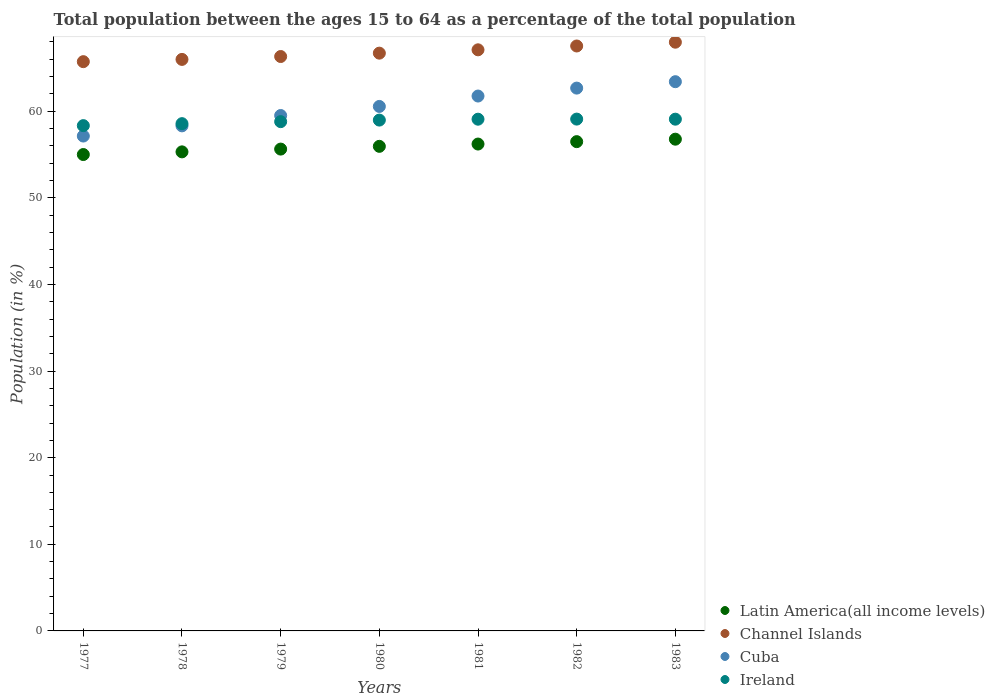How many different coloured dotlines are there?
Provide a succinct answer. 4. Is the number of dotlines equal to the number of legend labels?
Keep it short and to the point. Yes. What is the percentage of the population ages 15 to 64 in Channel Islands in 1980?
Your answer should be compact. 66.71. Across all years, what is the maximum percentage of the population ages 15 to 64 in Latin America(all income levels)?
Your response must be concise. 56.78. Across all years, what is the minimum percentage of the population ages 15 to 64 in Latin America(all income levels)?
Make the answer very short. 55. What is the total percentage of the population ages 15 to 64 in Cuba in the graph?
Offer a very short reply. 423.38. What is the difference between the percentage of the population ages 15 to 64 in Ireland in 1979 and that in 1980?
Your answer should be very brief. -0.18. What is the difference between the percentage of the population ages 15 to 64 in Latin America(all income levels) in 1983 and the percentage of the population ages 15 to 64 in Ireland in 1977?
Make the answer very short. -1.56. What is the average percentage of the population ages 15 to 64 in Latin America(all income levels) per year?
Your answer should be compact. 55.91. In the year 1983, what is the difference between the percentage of the population ages 15 to 64 in Ireland and percentage of the population ages 15 to 64 in Latin America(all income levels)?
Your response must be concise. 2.31. In how many years, is the percentage of the population ages 15 to 64 in Ireland greater than 58?
Give a very brief answer. 7. What is the ratio of the percentage of the population ages 15 to 64 in Ireland in 1977 to that in 1980?
Your answer should be very brief. 0.99. Is the difference between the percentage of the population ages 15 to 64 in Ireland in 1979 and 1980 greater than the difference between the percentage of the population ages 15 to 64 in Latin America(all income levels) in 1979 and 1980?
Provide a succinct answer. Yes. What is the difference between the highest and the second highest percentage of the population ages 15 to 64 in Latin America(all income levels)?
Keep it short and to the point. 0.28. What is the difference between the highest and the lowest percentage of the population ages 15 to 64 in Cuba?
Make the answer very short. 6.28. Is it the case that in every year, the sum of the percentage of the population ages 15 to 64 in Latin America(all income levels) and percentage of the population ages 15 to 64 in Channel Islands  is greater than the sum of percentage of the population ages 15 to 64 in Ireland and percentage of the population ages 15 to 64 in Cuba?
Offer a terse response. Yes. Is it the case that in every year, the sum of the percentage of the population ages 15 to 64 in Ireland and percentage of the population ages 15 to 64 in Cuba  is greater than the percentage of the population ages 15 to 64 in Channel Islands?
Your answer should be very brief. Yes. Does the percentage of the population ages 15 to 64 in Cuba monotonically increase over the years?
Ensure brevity in your answer.  Yes. Is the percentage of the population ages 15 to 64 in Channel Islands strictly less than the percentage of the population ages 15 to 64 in Cuba over the years?
Ensure brevity in your answer.  No. Are the values on the major ticks of Y-axis written in scientific E-notation?
Give a very brief answer. No. Does the graph contain grids?
Give a very brief answer. No. Where does the legend appear in the graph?
Provide a short and direct response. Bottom right. How many legend labels are there?
Your answer should be very brief. 4. How are the legend labels stacked?
Provide a short and direct response. Vertical. What is the title of the graph?
Your response must be concise. Total population between the ages 15 to 64 as a percentage of the total population. What is the label or title of the Y-axis?
Your response must be concise. Population (in %). What is the Population (in %) in Latin America(all income levels) in 1977?
Give a very brief answer. 55. What is the Population (in %) in Channel Islands in 1977?
Your answer should be compact. 65.73. What is the Population (in %) in Cuba in 1977?
Offer a terse response. 57.14. What is the Population (in %) of Ireland in 1977?
Keep it short and to the point. 58.34. What is the Population (in %) of Latin America(all income levels) in 1978?
Offer a terse response. 55.31. What is the Population (in %) in Channel Islands in 1978?
Your answer should be compact. 65.99. What is the Population (in %) in Cuba in 1978?
Your answer should be compact. 58.32. What is the Population (in %) in Ireland in 1978?
Provide a short and direct response. 58.57. What is the Population (in %) in Latin America(all income levels) in 1979?
Keep it short and to the point. 55.63. What is the Population (in %) in Channel Islands in 1979?
Provide a short and direct response. 66.32. What is the Population (in %) of Cuba in 1979?
Make the answer very short. 59.51. What is the Population (in %) of Ireland in 1979?
Offer a terse response. 58.8. What is the Population (in %) of Latin America(all income levels) in 1980?
Make the answer very short. 55.95. What is the Population (in %) of Channel Islands in 1980?
Provide a succinct answer. 66.71. What is the Population (in %) of Cuba in 1980?
Your answer should be compact. 60.56. What is the Population (in %) of Ireland in 1980?
Give a very brief answer. 58.98. What is the Population (in %) in Latin America(all income levels) in 1981?
Your answer should be very brief. 56.22. What is the Population (in %) of Channel Islands in 1981?
Offer a very short reply. 67.1. What is the Population (in %) in Cuba in 1981?
Your response must be concise. 61.76. What is the Population (in %) in Ireland in 1981?
Offer a very short reply. 59.09. What is the Population (in %) of Latin America(all income levels) in 1982?
Give a very brief answer. 56.49. What is the Population (in %) in Channel Islands in 1982?
Make the answer very short. 67.54. What is the Population (in %) in Cuba in 1982?
Offer a terse response. 62.68. What is the Population (in %) in Ireland in 1982?
Provide a succinct answer. 59.1. What is the Population (in %) in Latin America(all income levels) in 1983?
Your answer should be compact. 56.78. What is the Population (in %) in Channel Islands in 1983?
Give a very brief answer. 67.98. What is the Population (in %) of Cuba in 1983?
Provide a succinct answer. 63.42. What is the Population (in %) of Ireland in 1983?
Provide a short and direct response. 59.09. Across all years, what is the maximum Population (in %) of Latin America(all income levels)?
Offer a very short reply. 56.78. Across all years, what is the maximum Population (in %) of Channel Islands?
Your response must be concise. 67.98. Across all years, what is the maximum Population (in %) in Cuba?
Make the answer very short. 63.42. Across all years, what is the maximum Population (in %) in Ireland?
Give a very brief answer. 59.1. Across all years, what is the minimum Population (in %) of Latin America(all income levels)?
Make the answer very short. 55. Across all years, what is the minimum Population (in %) in Channel Islands?
Your answer should be very brief. 65.73. Across all years, what is the minimum Population (in %) of Cuba?
Offer a very short reply. 57.14. Across all years, what is the minimum Population (in %) in Ireland?
Offer a terse response. 58.34. What is the total Population (in %) of Latin America(all income levels) in the graph?
Offer a very short reply. 391.39. What is the total Population (in %) in Channel Islands in the graph?
Offer a very short reply. 467.36. What is the total Population (in %) of Cuba in the graph?
Provide a short and direct response. 423.38. What is the total Population (in %) in Ireland in the graph?
Your answer should be very brief. 411.97. What is the difference between the Population (in %) of Latin America(all income levels) in 1977 and that in 1978?
Your answer should be very brief. -0.31. What is the difference between the Population (in %) of Channel Islands in 1977 and that in 1978?
Give a very brief answer. -0.26. What is the difference between the Population (in %) in Cuba in 1977 and that in 1978?
Your answer should be very brief. -1.18. What is the difference between the Population (in %) of Ireland in 1977 and that in 1978?
Offer a very short reply. -0.23. What is the difference between the Population (in %) of Latin America(all income levels) in 1977 and that in 1979?
Keep it short and to the point. -0.63. What is the difference between the Population (in %) of Channel Islands in 1977 and that in 1979?
Give a very brief answer. -0.59. What is the difference between the Population (in %) in Cuba in 1977 and that in 1979?
Give a very brief answer. -2.37. What is the difference between the Population (in %) in Ireland in 1977 and that in 1979?
Give a very brief answer. -0.46. What is the difference between the Population (in %) in Latin America(all income levels) in 1977 and that in 1980?
Your answer should be compact. -0.95. What is the difference between the Population (in %) in Channel Islands in 1977 and that in 1980?
Make the answer very short. -0.98. What is the difference between the Population (in %) of Cuba in 1977 and that in 1980?
Ensure brevity in your answer.  -3.42. What is the difference between the Population (in %) in Ireland in 1977 and that in 1980?
Ensure brevity in your answer.  -0.64. What is the difference between the Population (in %) in Latin America(all income levels) in 1977 and that in 1981?
Provide a short and direct response. -1.21. What is the difference between the Population (in %) of Channel Islands in 1977 and that in 1981?
Provide a succinct answer. -1.37. What is the difference between the Population (in %) in Cuba in 1977 and that in 1981?
Offer a terse response. -4.62. What is the difference between the Population (in %) of Ireland in 1977 and that in 1981?
Your answer should be very brief. -0.74. What is the difference between the Population (in %) of Latin America(all income levels) in 1977 and that in 1982?
Offer a terse response. -1.49. What is the difference between the Population (in %) of Channel Islands in 1977 and that in 1982?
Give a very brief answer. -1.81. What is the difference between the Population (in %) in Cuba in 1977 and that in 1982?
Your response must be concise. -5.54. What is the difference between the Population (in %) of Ireland in 1977 and that in 1982?
Make the answer very short. -0.76. What is the difference between the Population (in %) of Latin America(all income levels) in 1977 and that in 1983?
Your answer should be very brief. -1.77. What is the difference between the Population (in %) in Channel Islands in 1977 and that in 1983?
Your answer should be compact. -2.25. What is the difference between the Population (in %) in Cuba in 1977 and that in 1983?
Your response must be concise. -6.28. What is the difference between the Population (in %) in Ireland in 1977 and that in 1983?
Make the answer very short. -0.75. What is the difference between the Population (in %) in Latin America(all income levels) in 1978 and that in 1979?
Your response must be concise. -0.32. What is the difference between the Population (in %) of Channel Islands in 1978 and that in 1979?
Make the answer very short. -0.33. What is the difference between the Population (in %) in Cuba in 1978 and that in 1979?
Provide a succinct answer. -1.19. What is the difference between the Population (in %) of Ireland in 1978 and that in 1979?
Give a very brief answer. -0.23. What is the difference between the Population (in %) in Latin America(all income levels) in 1978 and that in 1980?
Ensure brevity in your answer.  -0.64. What is the difference between the Population (in %) in Channel Islands in 1978 and that in 1980?
Ensure brevity in your answer.  -0.72. What is the difference between the Population (in %) of Cuba in 1978 and that in 1980?
Give a very brief answer. -2.24. What is the difference between the Population (in %) of Ireland in 1978 and that in 1980?
Your answer should be very brief. -0.41. What is the difference between the Population (in %) of Latin America(all income levels) in 1978 and that in 1981?
Provide a succinct answer. -0.9. What is the difference between the Population (in %) of Channel Islands in 1978 and that in 1981?
Your answer should be compact. -1.11. What is the difference between the Population (in %) of Cuba in 1978 and that in 1981?
Provide a succinct answer. -3.44. What is the difference between the Population (in %) in Ireland in 1978 and that in 1981?
Your response must be concise. -0.51. What is the difference between the Population (in %) in Latin America(all income levels) in 1978 and that in 1982?
Provide a succinct answer. -1.18. What is the difference between the Population (in %) in Channel Islands in 1978 and that in 1982?
Make the answer very short. -1.55. What is the difference between the Population (in %) in Cuba in 1978 and that in 1982?
Offer a very short reply. -4.36. What is the difference between the Population (in %) in Ireland in 1978 and that in 1982?
Provide a succinct answer. -0.53. What is the difference between the Population (in %) in Latin America(all income levels) in 1978 and that in 1983?
Give a very brief answer. -1.46. What is the difference between the Population (in %) of Channel Islands in 1978 and that in 1983?
Ensure brevity in your answer.  -1.99. What is the difference between the Population (in %) in Cuba in 1978 and that in 1983?
Offer a very short reply. -5.1. What is the difference between the Population (in %) in Ireland in 1978 and that in 1983?
Provide a short and direct response. -0.52. What is the difference between the Population (in %) in Latin America(all income levels) in 1979 and that in 1980?
Give a very brief answer. -0.32. What is the difference between the Population (in %) in Channel Islands in 1979 and that in 1980?
Offer a terse response. -0.39. What is the difference between the Population (in %) in Cuba in 1979 and that in 1980?
Your response must be concise. -1.05. What is the difference between the Population (in %) in Ireland in 1979 and that in 1980?
Keep it short and to the point. -0.18. What is the difference between the Population (in %) of Latin America(all income levels) in 1979 and that in 1981?
Provide a succinct answer. -0.58. What is the difference between the Population (in %) in Channel Islands in 1979 and that in 1981?
Your answer should be very brief. -0.77. What is the difference between the Population (in %) of Cuba in 1979 and that in 1981?
Ensure brevity in your answer.  -2.25. What is the difference between the Population (in %) of Ireland in 1979 and that in 1981?
Provide a succinct answer. -0.28. What is the difference between the Population (in %) of Latin America(all income levels) in 1979 and that in 1982?
Provide a short and direct response. -0.86. What is the difference between the Population (in %) in Channel Islands in 1979 and that in 1982?
Provide a succinct answer. -1.22. What is the difference between the Population (in %) of Cuba in 1979 and that in 1982?
Offer a terse response. -3.17. What is the difference between the Population (in %) in Ireland in 1979 and that in 1982?
Provide a short and direct response. -0.29. What is the difference between the Population (in %) in Latin America(all income levels) in 1979 and that in 1983?
Offer a terse response. -1.14. What is the difference between the Population (in %) of Channel Islands in 1979 and that in 1983?
Make the answer very short. -1.65. What is the difference between the Population (in %) in Cuba in 1979 and that in 1983?
Your answer should be very brief. -3.9. What is the difference between the Population (in %) in Ireland in 1979 and that in 1983?
Give a very brief answer. -0.29. What is the difference between the Population (in %) of Latin America(all income levels) in 1980 and that in 1981?
Provide a short and direct response. -0.26. What is the difference between the Population (in %) in Channel Islands in 1980 and that in 1981?
Ensure brevity in your answer.  -0.38. What is the difference between the Population (in %) of Cuba in 1980 and that in 1981?
Provide a succinct answer. -1.2. What is the difference between the Population (in %) of Ireland in 1980 and that in 1981?
Offer a terse response. -0.1. What is the difference between the Population (in %) in Latin America(all income levels) in 1980 and that in 1982?
Your answer should be very brief. -0.54. What is the difference between the Population (in %) in Channel Islands in 1980 and that in 1982?
Provide a succinct answer. -0.83. What is the difference between the Population (in %) of Cuba in 1980 and that in 1982?
Provide a short and direct response. -2.12. What is the difference between the Population (in %) of Ireland in 1980 and that in 1982?
Ensure brevity in your answer.  -0.11. What is the difference between the Population (in %) in Latin America(all income levels) in 1980 and that in 1983?
Your answer should be compact. -0.83. What is the difference between the Population (in %) of Channel Islands in 1980 and that in 1983?
Keep it short and to the point. -1.27. What is the difference between the Population (in %) of Cuba in 1980 and that in 1983?
Provide a short and direct response. -2.86. What is the difference between the Population (in %) of Ireland in 1980 and that in 1983?
Your answer should be compact. -0.11. What is the difference between the Population (in %) in Latin America(all income levels) in 1981 and that in 1982?
Your answer should be compact. -0.28. What is the difference between the Population (in %) of Channel Islands in 1981 and that in 1982?
Give a very brief answer. -0.44. What is the difference between the Population (in %) of Cuba in 1981 and that in 1982?
Offer a very short reply. -0.92. What is the difference between the Population (in %) of Ireland in 1981 and that in 1982?
Offer a very short reply. -0.01. What is the difference between the Population (in %) of Latin America(all income levels) in 1981 and that in 1983?
Your answer should be compact. -0.56. What is the difference between the Population (in %) in Channel Islands in 1981 and that in 1983?
Offer a terse response. -0.88. What is the difference between the Population (in %) in Cuba in 1981 and that in 1983?
Ensure brevity in your answer.  -1.66. What is the difference between the Population (in %) of Ireland in 1981 and that in 1983?
Your answer should be compact. -0. What is the difference between the Population (in %) in Latin America(all income levels) in 1982 and that in 1983?
Keep it short and to the point. -0.28. What is the difference between the Population (in %) in Channel Islands in 1982 and that in 1983?
Provide a succinct answer. -0.44. What is the difference between the Population (in %) in Cuba in 1982 and that in 1983?
Your answer should be compact. -0.74. What is the difference between the Population (in %) of Ireland in 1982 and that in 1983?
Provide a short and direct response. 0.01. What is the difference between the Population (in %) of Latin America(all income levels) in 1977 and the Population (in %) of Channel Islands in 1978?
Your answer should be compact. -10.98. What is the difference between the Population (in %) in Latin America(all income levels) in 1977 and the Population (in %) in Cuba in 1978?
Your answer should be very brief. -3.31. What is the difference between the Population (in %) in Latin America(all income levels) in 1977 and the Population (in %) in Ireland in 1978?
Your response must be concise. -3.57. What is the difference between the Population (in %) in Channel Islands in 1977 and the Population (in %) in Cuba in 1978?
Keep it short and to the point. 7.41. What is the difference between the Population (in %) in Channel Islands in 1977 and the Population (in %) in Ireland in 1978?
Provide a succinct answer. 7.16. What is the difference between the Population (in %) in Cuba in 1977 and the Population (in %) in Ireland in 1978?
Provide a short and direct response. -1.43. What is the difference between the Population (in %) in Latin America(all income levels) in 1977 and the Population (in %) in Channel Islands in 1979?
Your response must be concise. -11.32. What is the difference between the Population (in %) of Latin America(all income levels) in 1977 and the Population (in %) of Cuba in 1979?
Offer a very short reply. -4.51. What is the difference between the Population (in %) of Latin America(all income levels) in 1977 and the Population (in %) of Ireland in 1979?
Offer a very short reply. -3.8. What is the difference between the Population (in %) of Channel Islands in 1977 and the Population (in %) of Cuba in 1979?
Offer a very short reply. 6.22. What is the difference between the Population (in %) in Channel Islands in 1977 and the Population (in %) in Ireland in 1979?
Give a very brief answer. 6.93. What is the difference between the Population (in %) in Cuba in 1977 and the Population (in %) in Ireland in 1979?
Provide a succinct answer. -1.66. What is the difference between the Population (in %) of Latin America(all income levels) in 1977 and the Population (in %) of Channel Islands in 1980?
Make the answer very short. -11.71. What is the difference between the Population (in %) in Latin America(all income levels) in 1977 and the Population (in %) in Cuba in 1980?
Your answer should be very brief. -5.55. What is the difference between the Population (in %) in Latin America(all income levels) in 1977 and the Population (in %) in Ireland in 1980?
Give a very brief answer. -3.98. What is the difference between the Population (in %) of Channel Islands in 1977 and the Population (in %) of Cuba in 1980?
Make the answer very short. 5.17. What is the difference between the Population (in %) in Channel Islands in 1977 and the Population (in %) in Ireland in 1980?
Your response must be concise. 6.75. What is the difference between the Population (in %) in Cuba in 1977 and the Population (in %) in Ireland in 1980?
Give a very brief answer. -1.84. What is the difference between the Population (in %) of Latin America(all income levels) in 1977 and the Population (in %) of Channel Islands in 1981?
Offer a very short reply. -12.09. What is the difference between the Population (in %) in Latin America(all income levels) in 1977 and the Population (in %) in Cuba in 1981?
Provide a succinct answer. -6.75. What is the difference between the Population (in %) of Latin America(all income levels) in 1977 and the Population (in %) of Ireland in 1981?
Provide a short and direct response. -4.08. What is the difference between the Population (in %) in Channel Islands in 1977 and the Population (in %) in Cuba in 1981?
Keep it short and to the point. 3.97. What is the difference between the Population (in %) in Channel Islands in 1977 and the Population (in %) in Ireland in 1981?
Keep it short and to the point. 6.64. What is the difference between the Population (in %) of Cuba in 1977 and the Population (in %) of Ireland in 1981?
Provide a short and direct response. -1.95. What is the difference between the Population (in %) of Latin America(all income levels) in 1977 and the Population (in %) of Channel Islands in 1982?
Give a very brief answer. -12.53. What is the difference between the Population (in %) in Latin America(all income levels) in 1977 and the Population (in %) in Cuba in 1982?
Ensure brevity in your answer.  -7.67. What is the difference between the Population (in %) in Latin America(all income levels) in 1977 and the Population (in %) in Ireland in 1982?
Offer a very short reply. -4.09. What is the difference between the Population (in %) in Channel Islands in 1977 and the Population (in %) in Cuba in 1982?
Provide a short and direct response. 3.05. What is the difference between the Population (in %) in Channel Islands in 1977 and the Population (in %) in Ireland in 1982?
Provide a succinct answer. 6.63. What is the difference between the Population (in %) of Cuba in 1977 and the Population (in %) of Ireland in 1982?
Your answer should be very brief. -1.96. What is the difference between the Population (in %) in Latin America(all income levels) in 1977 and the Population (in %) in Channel Islands in 1983?
Give a very brief answer. -12.97. What is the difference between the Population (in %) in Latin America(all income levels) in 1977 and the Population (in %) in Cuba in 1983?
Ensure brevity in your answer.  -8.41. What is the difference between the Population (in %) in Latin America(all income levels) in 1977 and the Population (in %) in Ireland in 1983?
Your answer should be very brief. -4.08. What is the difference between the Population (in %) of Channel Islands in 1977 and the Population (in %) of Cuba in 1983?
Make the answer very short. 2.31. What is the difference between the Population (in %) in Channel Islands in 1977 and the Population (in %) in Ireland in 1983?
Make the answer very short. 6.64. What is the difference between the Population (in %) of Cuba in 1977 and the Population (in %) of Ireland in 1983?
Your response must be concise. -1.95. What is the difference between the Population (in %) in Latin America(all income levels) in 1978 and the Population (in %) in Channel Islands in 1979?
Your response must be concise. -11.01. What is the difference between the Population (in %) of Latin America(all income levels) in 1978 and the Population (in %) of Cuba in 1979?
Ensure brevity in your answer.  -4.2. What is the difference between the Population (in %) of Latin America(all income levels) in 1978 and the Population (in %) of Ireland in 1979?
Your answer should be very brief. -3.49. What is the difference between the Population (in %) of Channel Islands in 1978 and the Population (in %) of Cuba in 1979?
Make the answer very short. 6.48. What is the difference between the Population (in %) of Channel Islands in 1978 and the Population (in %) of Ireland in 1979?
Make the answer very short. 7.19. What is the difference between the Population (in %) in Cuba in 1978 and the Population (in %) in Ireland in 1979?
Provide a succinct answer. -0.49. What is the difference between the Population (in %) of Latin America(all income levels) in 1978 and the Population (in %) of Channel Islands in 1980?
Your answer should be compact. -11.4. What is the difference between the Population (in %) in Latin America(all income levels) in 1978 and the Population (in %) in Cuba in 1980?
Ensure brevity in your answer.  -5.24. What is the difference between the Population (in %) in Latin America(all income levels) in 1978 and the Population (in %) in Ireland in 1980?
Make the answer very short. -3.67. What is the difference between the Population (in %) of Channel Islands in 1978 and the Population (in %) of Cuba in 1980?
Offer a very short reply. 5.43. What is the difference between the Population (in %) of Channel Islands in 1978 and the Population (in %) of Ireland in 1980?
Your response must be concise. 7.01. What is the difference between the Population (in %) of Cuba in 1978 and the Population (in %) of Ireland in 1980?
Offer a terse response. -0.67. What is the difference between the Population (in %) of Latin America(all income levels) in 1978 and the Population (in %) of Channel Islands in 1981?
Keep it short and to the point. -11.78. What is the difference between the Population (in %) in Latin America(all income levels) in 1978 and the Population (in %) in Cuba in 1981?
Offer a terse response. -6.44. What is the difference between the Population (in %) in Latin America(all income levels) in 1978 and the Population (in %) in Ireland in 1981?
Offer a terse response. -3.77. What is the difference between the Population (in %) of Channel Islands in 1978 and the Population (in %) of Cuba in 1981?
Your response must be concise. 4.23. What is the difference between the Population (in %) in Channel Islands in 1978 and the Population (in %) in Ireland in 1981?
Offer a very short reply. 6.9. What is the difference between the Population (in %) in Cuba in 1978 and the Population (in %) in Ireland in 1981?
Offer a very short reply. -0.77. What is the difference between the Population (in %) in Latin America(all income levels) in 1978 and the Population (in %) in Channel Islands in 1982?
Provide a succinct answer. -12.22. What is the difference between the Population (in %) of Latin America(all income levels) in 1978 and the Population (in %) of Cuba in 1982?
Offer a very short reply. -7.36. What is the difference between the Population (in %) of Latin America(all income levels) in 1978 and the Population (in %) of Ireland in 1982?
Make the answer very short. -3.78. What is the difference between the Population (in %) of Channel Islands in 1978 and the Population (in %) of Cuba in 1982?
Keep it short and to the point. 3.31. What is the difference between the Population (in %) in Channel Islands in 1978 and the Population (in %) in Ireland in 1982?
Your answer should be compact. 6.89. What is the difference between the Population (in %) of Cuba in 1978 and the Population (in %) of Ireland in 1982?
Give a very brief answer. -0.78. What is the difference between the Population (in %) of Latin America(all income levels) in 1978 and the Population (in %) of Channel Islands in 1983?
Your response must be concise. -12.66. What is the difference between the Population (in %) in Latin America(all income levels) in 1978 and the Population (in %) in Cuba in 1983?
Provide a short and direct response. -8.1. What is the difference between the Population (in %) of Latin America(all income levels) in 1978 and the Population (in %) of Ireland in 1983?
Provide a short and direct response. -3.77. What is the difference between the Population (in %) of Channel Islands in 1978 and the Population (in %) of Cuba in 1983?
Your response must be concise. 2.57. What is the difference between the Population (in %) in Channel Islands in 1978 and the Population (in %) in Ireland in 1983?
Provide a short and direct response. 6.9. What is the difference between the Population (in %) in Cuba in 1978 and the Population (in %) in Ireland in 1983?
Ensure brevity in your answer.  -0.77. What is the difference between the Population (in %) in Latin America(all income levels) in 1979 and the Population (in %) in Channel Islands in 1980?
Provide a succinct answer. -11.08. What is the difference between the Population (in %) in Latin America(all income levels) in 1979 and the Population (in %) in Cuba in 1980?
Ensure brevity in your answer.  -4.92. What is the difference between the Population (in %) in Latin America(all income levels) in 1979 and the Population (in %) in Ireland in 1980?
Keep it short and to the point. -3.35. What is the difference between the Population (in %) in Channel Islands in 1979 and the Population (in %) in Cuba in 1980?
Offer a very short reply. 5.76. What is the difference between the Population (in %) of Channel Islands in 1979 and the Population (in %) of Ireland in 1980?
Your answer should be compact. 7.34. What is the difference between the Population (in %) of Cuba in 1979 and the Population (in %) of Ireland in 1980?
Offer a very short reply. 0.53. What is the difference between the Population (in %) in Latin America(all income levels) in 1979 and the Population (in %) in Channel Islands in 1981?
Provide a short and direct response. -11.46. What is the difference between the Population (in %) in Latin America(all income levels) in 1979 and the Population (in %) in Cuba in 1981?
Make the answer very short. -6.12. What is the difference between the Population (in %) of Latin America(all income levels) in 1979 and the Population (in %) of Ireland in 1981?
Offer a terse response. -3.45. What is the difference between the Population (in %) in Channel Islands in 1979 and the Population (in %) in Cuba in 1981?
Keep it short and to the point. 4.56. What is the difference between the Population (in %) in Channel Islands in 1979 and the Population (in %) in Ireland in 1981?
Your answer should be very brief. 7.24. What is the difference between the Population (in %) in Cuba in 1979 and the Population (in %) in Ireland in 1981?
Keep it short and to the point. 0.43. What is the difference between the Population (in %) in Latin America(all income levels) in 1979 and the Population (in %) in Channel Islands in 1982?
Ensure brevity in your answer.  -11.9. What is the difference between the Population (in %) in Latin America(all income levels) in 1979 and the Population (in %) in Cuba in 1982?
Your answer should be compact. -7.04. What is the difference between the Population (in %) in Latin America(all income levels) in 1979 and the Population (in %) in Ireland in 1982?
Offer a terse response. -3.46. What is the difference between the Population (in %) of Channel Islands in 1979 and the Population (in %) of Cuba in 1982?
Offer a very short reply. 3.65. What is the difference between the Population (in %) in Channel Islands in 1979 and the Population (in %) in Ireland in 1982?
Provide a short and direct response. 7.23. What is the difference between the Population (in %) of Cuba in 1979 and the Population (in %) of Ireland in 1982?
Offer a very short reply. 0.41. What is the difference between the Population (in %) of Latin America(all income levels) in 1979 and the Population (in %) of Channel Islands in 1983?
Keep it short and to the point. -12.34. What is the difference between the Population (in %) of Latin America(all income levels) in 1979 and the Population (in %) of Cuba in 1983?
Give a very brief answer. -7.78. What is the difference between the Population (in %) of Latin America(all income levels) in 1979 and the Population (in %) of Ireland in 1983?
Offer a terse response. -3.45. What is the difference between the Population (in %) of Channel Islands in 1979 and the Population (in %) of Cuba in 1983?
Your answer should be very brief. 2.91. What is the difference between the Population (in %) of Channel Islands in 1979 and the Population (in %) of Ireland in 1983?
Your answer should be compact. 7.23. What is the difference between the Population (in %) of Cuba in 1979 and the Population (in %) of Ireland in 1983?
Your answer should be compact. 0.42. What is the difference between the Population (in %) in Latin America(all income levels) in 1980 and the Population (in %) in Channel Islands in 1981?
Offer a very short reply. -11.14. What is the difference between the Population (in %) in Latin America(all income levels) in 1980 and the Population (in %) in Cuba in 1981?
Your answer should be very brief. -5.81. What is the difference between the Population (in %) in Latin America(all income levels) in 1980 and the Population (in %) in Ireland in 1981?
Offer a very short reply. -3.13. What is the difference between the Population (in %) in Channel Islands in 1980 and the Population (in %) in Cuba in 1981?
Provide a succinct answer. 4.95. What is the difference between the Population (in %) of Channel Islands in 1980 and the Population (in %) of Ireland in 1981?
Give a very brief answer. 7.63. What is the difference between the Population (in %) of Cuba in 1980 and the Population (in %) of Ireland in 1981?
Make the answer very short. 1.47. What is the difference between the Population (in %) in Latin America(all income levels) in 1980 and the Population (in %) in Channel Islands in 1982?
Your response must be concise. -11.59. What is the difference between the Population (in %) of Latin America(all income levels) in 1980 and the Population (in %) of Cuba in 1982?
Offer a very short reply. -6.72. What is the difference between the Population (in %) in Latin America(all income levels) in 1980 and the Population (in %) in Ireland in 1982?
Your answer should be compact. -3.15. What is the difference between the Population (in %) in Channel Islands in 1980 and the Population (in %) in Cuba in 1982?
Provide a short and direct response. 4.04. What is the difference between the Population (in %) of Channel Islands in 1980 and the Population (in %) of Ireland in 1982?
Ensure brevity in your answer.  7.61. What is the difference between the Population (in %) of Cuba in 1980 and the Population (in %) of Ireland in 1982?
Provide a succinct answer. 1.46. What is the difference between the Population (in %) of Latin America(all income levels) in 1980 and the Population (in %) of Channel Islands in 1983?
Make the answer very short. -12.02. What is the difference between the Population (in %) of Latin America(all income levels) in 1980 and the Population (in %) of Cuba in 1983?
Provide a succinct answer. -7.46. What is the difference between the Population (in %) in Latin America(all income levels) in 1980 and the Population (in %) in Ireland in 1983?
Provide a succinct answer. -3.14. What is the difference between the Population (in %) of Channel Islands in 1980 and the Population (in %) of Cuba in 1983?
Keep it short and to the point. 3.3. What is the difference between the Population (in %) of Channel Islands in 1980 and the Population (in %) of Ireland in 1983?
Your answer should be compact. 7.62. What is the difference between the Population (in %) in Cuba in 1980 and the Population (in %) in Ireland in 1983?
Provide a short and direct response. 1.47. What is the difference between the Population (in %) of Latin America(all income levels) in 1981 and the Population (in %) of Channel Islands in 1982?
Provide a short and direct response. -11.32. What is the difference between the Population (in %) in Latin America(all income levels) in 1981 and the Population (in %) in Cuba in 1982?
Provide a short and direct response. -6.46. What is the difference between the Population (in %) in Latin America(all income levels) in 1981 and the Population (in %) in Ireland in 1982?
Ensure brevity in your answer.  -2.88. What is the difference between the Population (in %) of Channel Islands in 1981 and the Population (in %) of Cuba in 1982?
Keep it short and to the point. 4.42. What is the difference between the Population (in %) in Channel Islands in 1981 and the Population (in %) in Ireland in 1982?
Ensure brevity in your answer.  8. What is the difference between the Population (in %) of Cuba in 1981 and the Population (in %) of Ireland in 1982?
Your response must be concise. 2.66. What is the difference between the Population (in %) of Latin America(all income levels) in 1981 and the Population (in %) of Channel Islands in 1983?
Give a very brief answer. -11.76. What is the difference between the Population (in %) of Latin America(all income levels) in 1981 and the Population (in %) of Cuba in 1983?
Keep it short and to the point. -7.2. What is the difference between the Population (in %) of Latin America(all income levels) in 1981 and the Population (in %) of Ireland in 1983?
Provide a succinct answer. -2.87. What is the difference between the Population (in %) in Channel Islands in 1981 and the Population (in %) in Cuba in 1983?
Offer a terse response. 3.68. What is the difference between the Population (in %) in Channel Islands in 1981 and the Population (in %) in Ireland in 1983?
Offer a terse response. 8.01. What is the difference between the Population (in %) in Cuba in 1981 and the Population (in %) in Ireland in 1983?
Make the answer very short. 2.67. What is the difference between the Population (in %) in Latin America(all income levels) in 1982 and the Population (in %) in Channel Islands in 1983?
Give a very brief answer. -11.48. What is the difference between the Population (in %) in Latin America(all income levels) in 1982 and the Population (in %) in Cuba in 1983?
Offer a very short reply. -6.92. What is the difference between the Population (in %) of Latin America(all income levels) in 1982 and the Population (in %) of Ireland in 1983?
Offer a very short reply. -2.59. What is the difference between the Population (in %) of Channel Islands in 1982 and the Population (in %) of Cuba in 1983?
Offer a terse response. 4.12. What is the difference between the Population (in %) of Channel Islands in 1982 and the Population (in %) of Ireland in 1983?
Ensure brevity in your answer.  8.45. What is the difference between the Population (in %) of Cuba in 1982 and the Population (in %) of Ireland in 1983?
Provide a succinct answer. 3.59. What is the average Population (in %) of Latin America(all income levels) per year?
Ensure brevity in your answer.  55.91. What is the average Population (in %) in Channel Islands per year?
Keep it short and to the point. 66.77. What is the average Population (in %) in Cuba per year?
Your answer should be compact. 60.48. What is the average Population (in %) of Ireland per year?
Provide a succinct answer. 58.85. In the year 1977, what is the difference between the Population (in %) of Latin America(all income levels) and Population (in %) of Channel Islands?
Give a very brief answer. -10.72. In the year 1977, what is the difference between the Population (in %) of Latin America(all income levels) and Population (in %) of Cuba?
Offer a terse response. -2.14. In the year 1977, what is the difference between the Population (in %) in Latin America(all income levels) and Population (in %) in Ireland?
Ensure brevity in your answer.  -3.34. In the year 1977, what is the difference between the Population (in %) of Channel Islands and Population (in %) of Cuba?
Your answer should be compact. 8.59. In the year 1977, what is the difference between the Population (in %) of Channel Islands and Population (in %) of Ireland?
Offer a very short reply. 7.39. In the year 1977, what is the difference between the Population (in %) in Cuba and Population (in %) in Ireland?
Your response must be concise. -1.2. In the year 1978, what is the difference between the Population (in %) of Latin America(all income levels) and Population (in %) of Channel Islands?
Keep it short and to the point. -10.67. In the year 1978, what is the difference between the Population (in %) in Latin America(all income levels) and Population (in %) in Cuba?
Keep it short and to the point. -3. In the year 1978, what is the difference between the Population (in %) in Latin America(all income levels) and Population (in %) in Ireland?
Provide a succinct answer. -3.26. In the year 1978, what is the difference between the Population (in %) of Channel Islands and Population (in %) of Cuba?
Your answer should be very brief. 7.67. In the year 1978, what is the difference between the Population (in %) of Channel Islands and Population (in %) of Ireland?
Make the answer very short. 7.42. In the year 1978, what is the difference between the Population (in %) of Cuba and Population (in %) of Ireland?
Ensure brevity in your answer.  -0.25. In the year 1979, what is the difference between the Population (in %) in Latin America(all income levels) and Population (in %) in Channel Islands?
Give a very brief answer. -10.69. In the year 1979, what is the difference between the Population (in %) of Latin America(all income levels) and Population (in %) of Cuba?
Offer a very short reply. -3.88. In the year 1979, what is the difference between the Population (in %) in Latin America(all income levels) and Population (in %) in Ireland?
Your answer should be very brief. -3.17. In the year 1979, what is the difference between the Population (in %) of Channel Islands and Population (in %) of Cuba?
Keep it short and to the point. 6.81. In the year 1979, what is the difference between the Population (in %) in Channel Islands and Population (in %) in Ireland?
Provide a short and direct response. 7.52. In the year 1979, what is the difference between the Population (in %) of Cuba and Population (in %) of Ireland?
Provide a short and direct response. 0.71. In the year 1980, what is the difference between the Population (in %) in Latin America(all income levels) and Population (in %) in Channel Islands?
Ensure brevity in your answer.  -10.76. In the year 1980, what is the difference between the Population (in %) in Latin America(all income levels) and Population (in %) in Cuba?
Your answer should be very brief. -4.61. In the year 1980, what is the difference between the Population (in %) in Latin America(all income levels) and Population (in %) in Ireland?
Provide a short and direct response. -3.03. In the year 1980, what is the difference between the Population (in %) of Channel Islands and Population (in %) of Cuba?
Ensure brevity in your answer.  6.15. In the year 1980, what is the difference between the Population (in %) of Channel Islands and Population (in %) of Ireland?
Give a very brief answer. 7.73. In the year 1980, what is the difference between the Population (in %) of Cuba and Population (in %) of Ireland?
Your answer should be compact. 1.58. In the year 1981, what is the difference between the Population (in %) in Latin America(all income levels) and Population (in %) in Channel Islands?
Ensure brevity in your answer.  -10.88. In the year 1981, what is the difference between the Population (in %) of Latin America(all income levels) and Population (in %) of Cuba?
Ensure brevity in your answer.  -5.54. In the year 1981, what is the difference between the Population (in %) of Latin America(all income levels) and Population (in %) of Ireland?
Offer a terse response. -2.87. In the year 1981, what is the difference between the Population (in %) in Channel Islands and Population (in %) in Cuba?
Keep it short and to the point. 5.34. In the year 1981, what is the difference between the Population (in %) in Channel Islands and Population (in %) in Ireland?
Keep it short and to the point. 8.01. In the year 1981, what is the difference between the Population (in %) of Cuba and Population (in %) of Ireland?
Your answer should be very brief. 2.67. In the year 1982, what is the difference between the Population (in %) of Latin America(all income levels) and Population (in %) of Channel Islands?
Give a very brief answer. -11.05. In the year 1982, what is the difference between the Population (in %) of Latin America(all income levels) and Population (in %) of Cuba?
Your answer should be compact. -6.18. In the year 1982, what is the difference between the Population (in %) of Latin America(all income levels) and Population (in %) of Ireland?
Ensure brevity in your answer.  -2.6. In the year 1982, what is the difference between the Population (in %) of Channel Islands and Population (in %) of Cuba?
Provide a short and direct response. 4.86. In the year 1982, what is the difference between the Population (in %) in Channel Islands and Population (in %) in Ireland?
Provide a short and direct response. 8.44. In the year 1982, what is the difference between the Population (in %) in Cuba and Population (in %) in Ireland?
Your answer should be very brief. 3.58. In the year 1983, what is the difference between the Population (in %) in Latin America(all income levels) and Population (in %) in Channel Islands?
Make the answer very short. -11.2. In the year 1983, what is the difference between the Population (in %) in Latin America(all income levels) and Population (in %) in Cuba?
Give a very brief answer. -6.64. In the year 1983, what is the difference between the Population (in %) in Latin America(all income levels) and Population (in %) in Ireland?
Provide a short and direct response. -2.31. In the year 1983, what is the difference between the Population (in %) in Channel Islands and Population (in %) in Cuba?
Your answer should be very brief. 4.56. In the year 1983, what is the difference between the Population (in %) in Channel Islands and Population (in %) in Ireland?
Offer a very short reply. 8.89. In the year 1983, what is the difference between the Population (in %) in Cuba and Population (in %) in Ireland?
Provide a succinct answer. 4.33. What is the ratio of the Population (in %) in Latin America(all income levels) in 1977 to that in 1978?
Give a very brief answer. 0.99. What is the ratio of the Population (in %) in Channel Islands in 1977 to that in 1978?
Keep it short and to the point. 1. What is the ratio of the Population (in %) in Cuba in 1977 to that in 1978?
Keep it short and to the point. 0.98. What is the ratio of the Population (in %) in Latin America(all income levels) in 1977 to that in 1979?
Keep it short and to the point. 0.99. What is the ratio of the Population (in %) of Channel Islands in 1977 to that in 1979?
Offer a terse response. 0.99. What is the ratio of the Population (in %) of Cuba in 1977 to that in 1979?
Offer a very short reply. 0.96. What is the ratio of the Population (in %) of Ireland in 1977 to that in 1979?
Offer a very short reply. 0.99. What is the ratio of the Population (in %) in Latin America(all income levels) in 1977 to that in 1980?
Offer a very short reply. 0.98. What is the ratio of the Population (in %) of Cuba in 1977 to that in 1980?
Your answer should be compact. 0.94. What is the ratio of the Population (in %) of Latin America(all income levels) in 1977 to that in 1981?
Your answer should be very brief. 0.98. What is the ratio of the Population (in %) of Channel Islands in 1977 to that in 1981?
Provide a succinct answer. 0.98. What is the ratio of the Population (in %) of Cuba in 1977 to that in 1981?
Ensure brevity in your answer.  0.93. What is the ratio of the Population (in %) of Ireland in 1977 to that in 1981?
Offer a terse response. 0.99. What is the ratio of the Population (in %) of Latin America(all income levels) in 1977 to that in 1982?
Give a very brief answer. 0.97. What is the ratio of the Population (in %) of Channel Islands in 1977 to that in 1982?
Offer a terse response. 0.97. What is the ratio of the Population (in %) of Cuba in 1977 to that in 1982?
Ensure brevity in your answer.  0.91. What is the ratio of the Population (in %) of Ireland in 1977 to that in 1982?
Your response must be concise. 0.99. What is the ratio of the Population (in %) of Latin America(all income levels) in 1977 to that in 1983?
Give a very brief answer. 0.97. What is the ratio of the Population (in %) in Channel Islands in 1977 to that in 1983?
Your answer should be very brief. 0.97. What is the ratio of the Population (in %) in Cuba in 1977 to that in 1983?
Keep it short and to the point. 0.9. What is the ratio of the Population (in %) of Ireland in 1977 to that in 1983?
Keep it short and to the point. 0.99. What is the ratio of the Population (in %) in Latin America(all income levels) in 1978 to that in 1979?
Keep it short and to the point. 0.99. What is the ratio of the Population (in %) in Cuba in 1978 to that in 1979?
Ensure brevity in your answer.  0.98. What is the ratio of the Population (in %) in Ireland in 1978 to that in 1979?
Provide a succinct answer. 1. What is the ratio of the Population (in %) of Cuba in 1978 to that in 1980?
Make the answer very short. 0.96. What is the ratio of the Population (in %) in Ireland in 1978 to that in 1980?
Offer a terse response. 0.99. What is the ratio of the Population (in %) of Channel Islands in 1978 to that in 1981?
Your answer should be very brief. 0.98. What is the ratio of the Population (in %) of Cuba in 1978 to that in 1981?
Provide a succinct answer. 0.94. What is the ratio of the Population (in %) of Latin America(all income levels) in 1978 to that in 1982?
Make the answer very short. 0.98. What is the ratio of the Population (in %) in Channel Islands in 1978 to that in 1982?
Your answer should be very brief. 0.98. What is the ratio of the Population (in %) in Cuba in 1978 to that in 1982?
Ensure brevity in your answer.  0.93. What is the ratio of the Population (in %) in Ireland in 1978 to that in 1982?
Provide a succinct answer. 0.99. What is the ratio of the Population (in %) in Latin America(all income levels) in 1978 to that in 1983?
Offer a very short reply. 0.97. What is the ratio of the Population (in %) of Channel Islands in 1978 to that in 1983?
Make the answer very short. 0.97. What is the ratio of the Population (in %) in Cuba in 1978 to that in 1983?
Make the answer very short. 0.92. What is the ratio of the Population (in %) of Ireland in 1978 to that in 1983?
Give a very brief answer. 0.99. What is the ratio of the Population (in %) of Cuba in 1979 to that in 1980?
Give a very brief answer. 0.98. What is the ratio of the Population (in %) in Ireland in 1979 to that in 1980?
Give a very brief answer. 1. What is the ratio of the Population (in %) of Latin America(all income levels) in 1979 to that in 1981?
Offer a very short reply. 0.99. What is the ratio of the Population (in %) in Channel Islands in 1979 to that in 1981?
Your answer should be compact. 0.99. What is the ratio of the Population (in %) of Cuba in 1979 to that in 1981?
Provide a short and direct response. 0.96. What is the ratio of the Population (in %) of Channel Islands in 1979 to that in 1982?
Provide a succinct answer. 0.98. What is the ratio of the Population (in %) of Cuba in 1979 to that in 1982?
Ensure brevity in your answer.  0.95. What is the ratio of the Population (in %) in Latin America(all income levels) in 1979 to that in 1983?
Keep it short and to the point. 0.98. What is the ratio of the Population (in %) of Channel Islands in 1979 to that in 1983?
Your answer should be compact. 0.98. What is the ratio of the Population (in %) of Cuba in 1979 to that in 1983?
Your answer should be compact. 0.94. What is the ratio of the Population (in %) of Channel Islands in 1980 to that in 1981?
Make the answer very short. 0.99. What is the ratio of the Population (in %) of Cuba in 1980 to that in 1981?
Provide a short and direct response. 0.98. What is the ratio of the Population (in %) of Channel Islands in 1980 to that in 1982?
Keep it short and to the point. 0.99. What is the ratio of the Population (in %) in Cuba in 1980 to that in 1982?
Provide a succinct answer. 0.97. What is the ratio of the Population (in %) of Ireland in 1980 to that in 1982?
Offer a terse response. 1. What is the ratio of the Population (in %) of Latin America(all income levels) in 1980 to that in 1983?
Your response must be concise. 0.99. What is the ratio of the Population (in %) of Channel Islands in 1980 to that in 1983?
Ensure brevity in your answer.  0.98. What is the ratio of the Population (in %) in Cuba in 1980 to that in 1983?
Give a very brief answer. 0.95. What is the ratio of the Population (in %) of Ireland in 1980 to that in 1983?
Provide a short and direct response. 1. What is the ratio of the Population (in %) of Cuba in 1981 to that in 1982?
Ensure brevity in your answer.  0.99. What is the ratio of the Population (in %) in Latin America(all income levels) in 1981 to that in 1983?
Your answer should be very brief. 0.99. What is the ratio of the Population (in %) of Cuba in 1981 to that in 1983?
Offer a very short reply. 0.97. What is the ratio of the Population (in %) of Ireland in 1981 to that in 1983?
Make the answer very short. 1. What is the ratio of the Population (in %) of Latin America(all income levels) in 1982 to that in 1983?
Provide a short and direct response. 0.99. What is the ratio of the Population (in %) of Channel Islands in 1982 to that in 1983?
Your response must be concise. 0.99. What is the ratio of the Population (in %) of Cuba in 1982 to that in 1983?
Keep it short and to the point. 0.99. What is the difference between the highest and the second highest Population (in %) of Latin America(all income levels)?
Give a very brief answer. 0.28. What is the difference between the highest and the second highest Population (in %) of Channel Islands?
Offer a terse response. 0.44. What is the difference between the highest and the second highest Population (in %) in Cuba?
Offer a very short reply. 0.74. What is the difference between the highest and the second highest Population (in %) of Ireland?
Give a very brief answer. 0.01. What is the difference between the highest and the lowest Population (in %) of Latin America(all income levels)?
Offer a very short reply. 1.77. What is the difference between the highest and the lowest Population (in %) of Channel Islands?
Your answer should be compact. 2.25. What is the difference between the highest and the lowest Population (in %) of Cuba?
Offer a terse response. 6.28. What is the difference between the highest and the lowest Population (in %) of Ireland?
Keep it short and to the point. 0.76. 